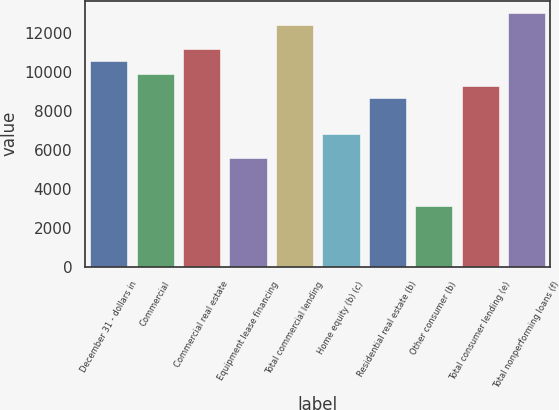Convert chart to OTSL. <chart><loc_0><loc_0><loc_500><loc_500><bar_chart><fcel>December 31 - dollars in<fcel>Commercial<fcel>Commercial real estate<fcel>Equipment lease financing<fcel>Total commercial lending<fcel>Home equity (b) (c)<fcel>Residential real estate (b)<fcel>Other consumer (b)<fcel>Total consumer lending (e)<fcel>Total nonperforming loans (f)<nl><fcel>10545.6<fcel>9925.39<fcel>11165.9<fcel>5583.78<fcel>12406.3<fcel>6824.24<fcel>8684.93<fcel>3102.86<fcel>9305.16<fcel>13026.5<nl></chart> 